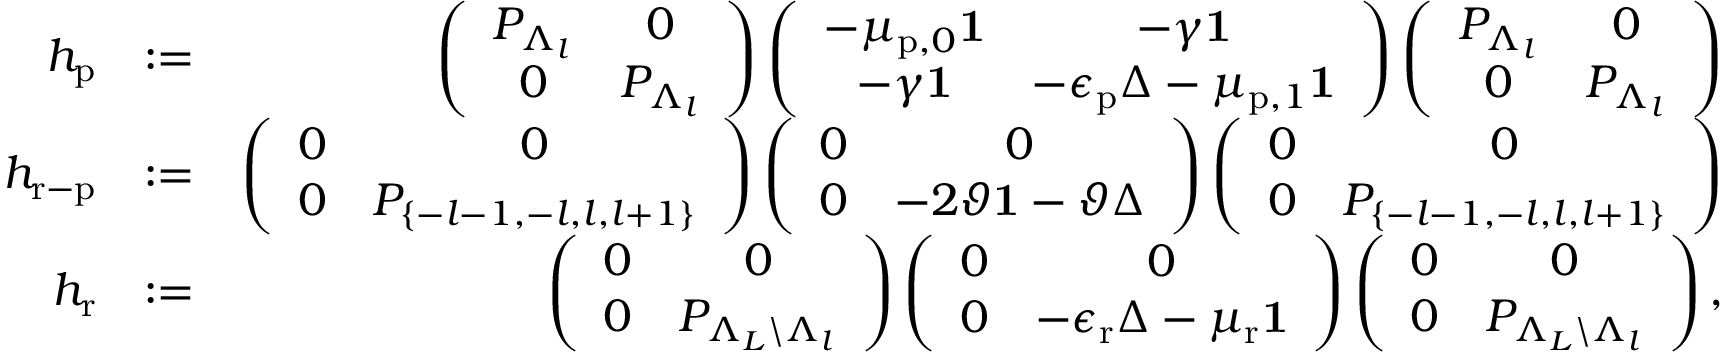Convert formula to latex. <formula><loc_0><loc_0><loc_500><loc_500>\begin{array} { r l r } { h _ { p } } & { \colon = } & { \left ( \begin{array} { c c } { P _ { \Lambda _ { l } } } & { 0 } \\ { 0 } & { P _ { \Lambda _ { l } } } \end{array} \right ) \left ( \begin{array} { c c } { - \mu _ { p , 0 } 1 } & { - \gamma 1 } \\ { - \gamma 1 } & { - \epsilon _ { p } \Delta - \mu _ { p , 1 } 1 } \end{array} \right ) \left ( \begin{array} { c c } { P _ { \Lambda _ { l } } } & { 0 } \\ { 0 } & { P _ { \Lambda _ { l } } } \end{array} \right ) } \\ { h _ { r - p } } & { \colon = } & { \left ( \begin{array} { c c } { 0 } & { 0 } \\ { 0 } & { P _ { \{ - l - 1 , - l , l , l + 1 \} } } \end{array} \right ) \left ( \begin{array} { c c } { 0 } & { 0 } \\ { 0 } & { - 2 \vartheta 1 - \vartheta \Delta } \end{array} \right ) \left ( \begin{array} { c c } { 0 } & { 0 } \\ { 0 } & { P _ { \{ - l - 1 , - l , l , l + 1 \} } } \end{array} \right ) } \\ { h _ { r } } & { \colon = } & { \left ( \begin{array} { c c } { 0 } & { 0 } \\ { 0 } & { P _ { \Lambda _ { L } \ \Lambda _ { l } } } \end{array} \right ) \left ( \begin{array} { c c } { 0 } & { 0 } \\ { 0 } & { - \epsilon _ { r } \Delta - \mu _ { r } 1 } \end{array} \right ) \left ( \begin{array} { c c } { 0 } & { 0 } \\ { 0 } & { P _ { \Lambda _ { L } \ \Lambda _ { l } } } \end{array} \right ) , } \end{array}</formula> 